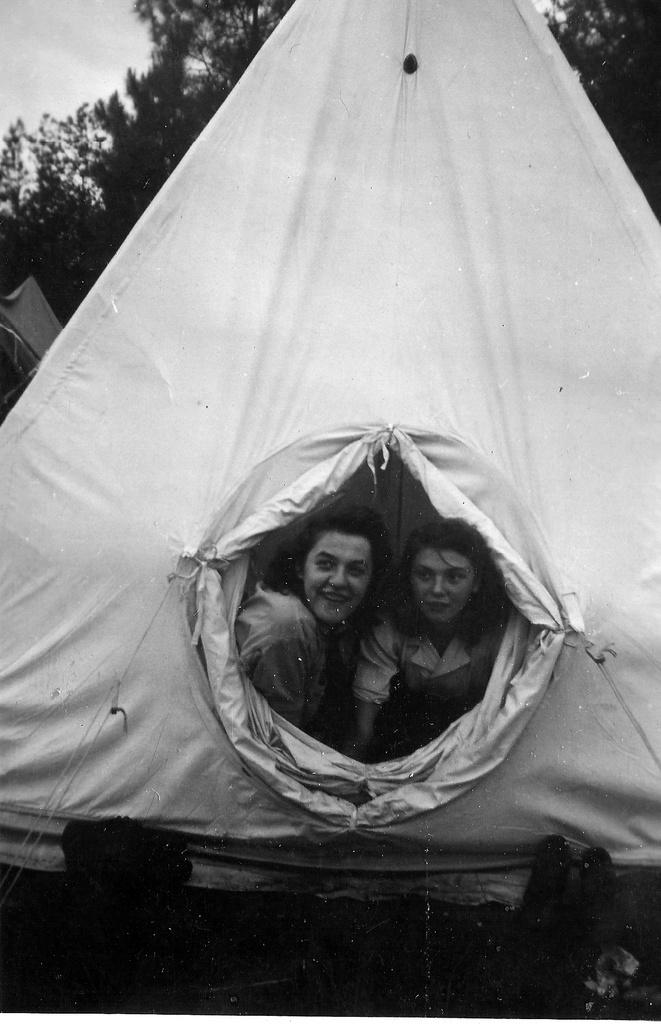How many women are in the foreground of the image? There are two women in the foreground of the image. What are the women doing in the image? The women are peeing outside in the image. How are the women using the hole in the tent? The women are using a hole in a tent for their activity. What can be seen in the background of the image? There are trees and the sky visible in the background of the image. What type of dog can be seen playing with a ball in the image? There is no dog or ball present in the image; it features two women using a hole in a tent. 